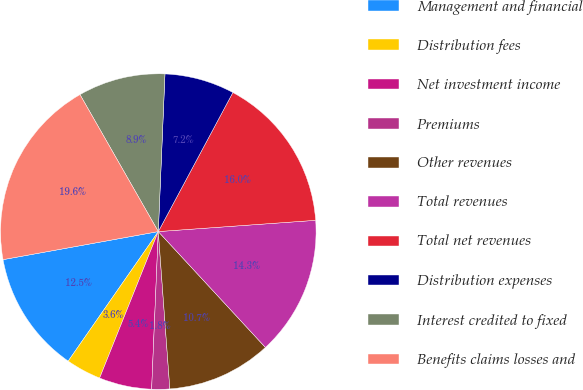Convert chart to OTSL. <chart><loc_0><loc_0><loc_500><loc_500><pie_chart><fcel>Management and financial<fcel>Distribution fees<fcel>Net investment income<fcel>Premiums<fcel>Other revenues<fcel>Total revenues<fcel>Total net revenues<fcel>Distribution expenses<fcel>Interest credited to fixed<fcel>Benefits claims losses and<nl><fcel>12.48%<fcel>3.61%<fcel>5.39%<fcel>1.84%<fcel>10.71%<fcel>14.26%<fcel>16.03%<fcel>7.16%<fcel>8.94%<fcel>19.58%<nl></chart> 